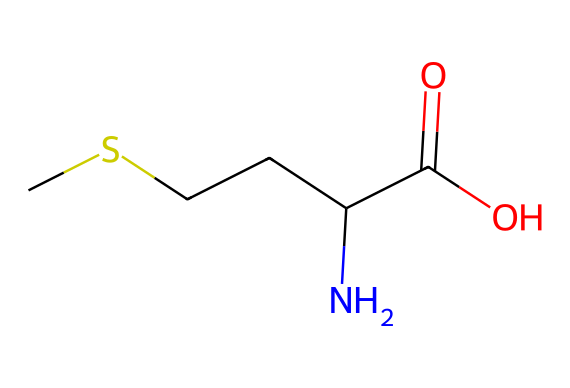What is the main functional group in this compound? The chemical structure shows a carboxylic acid group (C(=O)O) at the end, which is characteristic of acids.
Answer: carboxylic acid How many carbon atoms are present in methionine? By counting the carbon atoms in the structure (CSCCC), we find there are five carbon atoms.
Answer: five What is the total number of nitrogen atoms in this structure? The structure shows one nitrogen atom (indicated by N) connected to the carbon chain.
Answer: one What is the significance of the sulfur atom in methionine? Methionine contains one sulfur atom (S), which is essential for various biological processes, including protein synthesis and muscle recovery.
Answer: essential How does the presence of the amino group affect this compound? The amino group (NH2) allows methionine to participate in protein synthesis, serving as a building block for muscles.
Answer: building block What distinguishes methionine as an essential amino acid? Methionine is called essential because the body cannot synthesize it, and it must be obtained through diet, which is depicted in its structure.
Answer: diet Does this compound contain any unsaturated bonds? In analyzing the structure, all carbon-carbon bonds appear to be saturated (single bonds), indicating no unsaturation.
Answer: no 